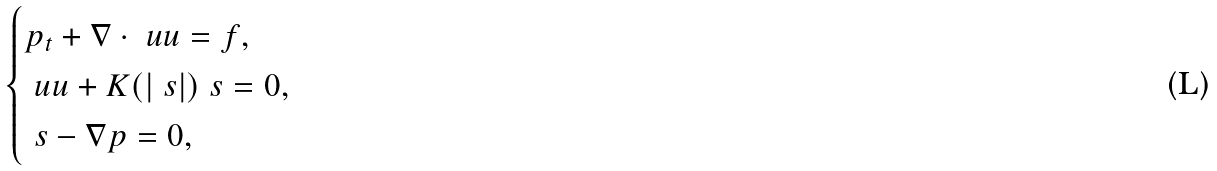<formula> <loc_0><loc_0><loc_500><loc_500>\begin{cases} p _ { t } + \nabla \cdot \ u u = f , \\ \ u u + K ( | \ s | ) \ s = 0 , \\ \ s - \nabla p = 0 , \end{cases}</formula> 